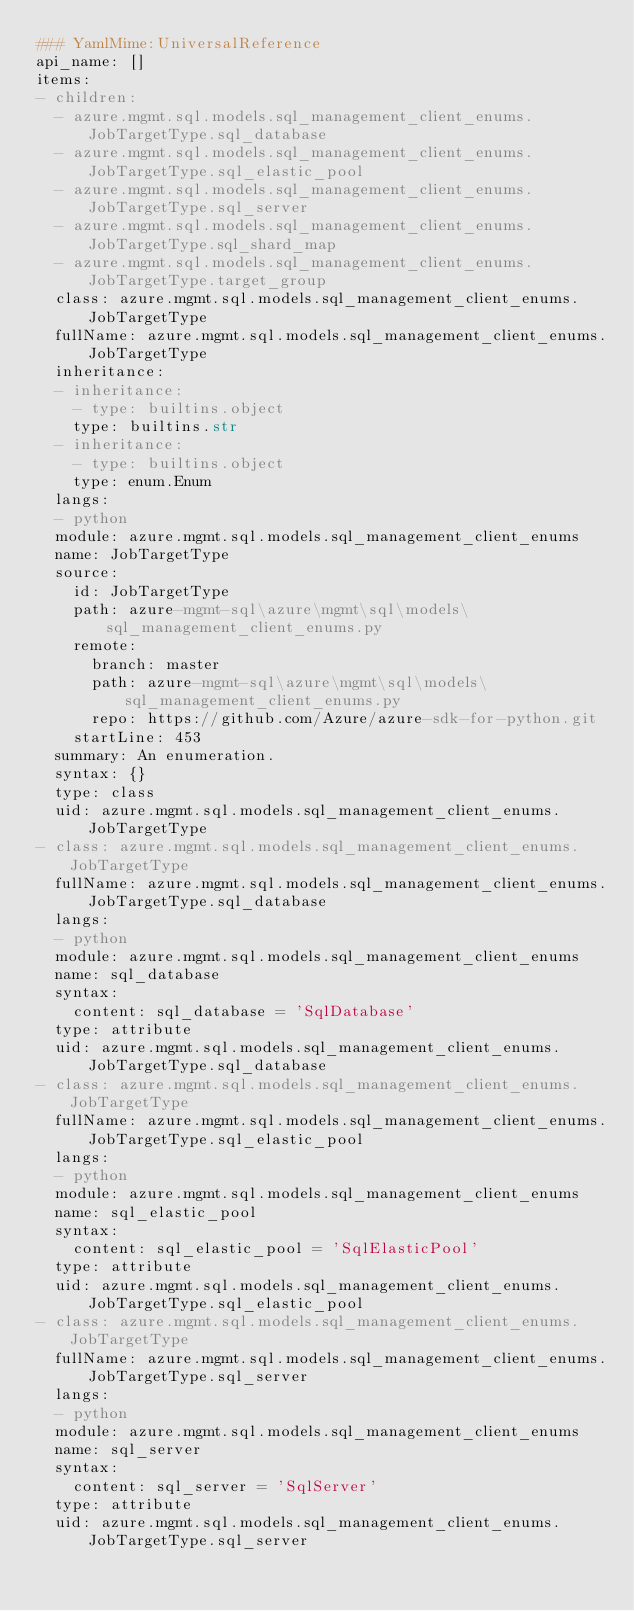Convert code to text. <code><loc_0><loc_0><loc_500><loc_500><_YAML_>### YamlMime:UniversalReference
api_name: []
items:
- children:
  - azure.mgmt.sql.models.sql_management_client_enums.JobTargetType.sql_database
  - azure.mgmt.sql.models.sql_management_client_enums.JobTargetType.sql_elastic_pool
  - azure.mgmt.sql.models.sql_management_client_enums.JobTargetType.sql_server
  - azure.mgmt.sql.models.sql_management_client_enums.JobTargetType.sql_shard_map
  - azure.mgmt.sql.models.sql_management_client_enums.JobTargetType.target_group
  class: azure.mgmt.sql.models.sql_management_client_enums.JobTargetType
  fullName: azure.mgmt.sql.models.sql_management_client_enums.JobTargetType
  inheritance:
  - inheritance:
    - type: builtins.object
    type: builtins.str
  - inheritance:
    - type: builtins.object
    type: enum.Enum
  langs:
  - python
  module: azure.mgmt.sql.models.sql_management_client_enums
  name: JobTargetType
  source:
    id: JobTargetType
    path: azure-mgmt-sql\azure\mgmt\sql\models\sql_management_client_enums.py
    remote:
      branch: master
      path: azure-mgmt-sql\azure\mgmt\sql\models\sql_management_client_enums.py
      repo: https://github.com/Azure/azure-sdk-for-python.git
    startLine: 453
  summary: An enumeration.
  syntax: {}
  type: class
  uid: azure.mgmt.sql.models.sql_management_client_enums.JobTargetType
- class: azure.mgmt.sql.models.sql_management_client_enums.JobTargetType
  fullName: azure.mgmt.sql.models.sql_management_client_enums.JobTargetType.sql_database
  langs:
  - python
  module: azure.mgmt.sql.models.sql_management_client_enums
  name: sql_database
  syntax:
    content: sql_database = 'SqlDatabase'
  type: attribute
  uid: azure.mgmt.sql.models.sql_management_client_enums.JobTargetType.sql_database
- class: azure.mgmt.sql.models.sql_management_client_enums.JobTargetType
  fullName: azure.mgmt.sql.models.sql_management_client_enums.JobTargetType.sql_elastic_pool
  langs:
  - python
  module: azure.mgmt.sql.models.sql_management_client_enums
  name: sql_elastic_pool
  syntax:
    content: sql_elastic_pool = 'SqlElasticPool'
  type: attribute
  uid: azure.mgmt.sql.models.sql_management_client_enums.JobTargetType.sql_elastic_pool
- class: azure.mgmt.sql.models.sql_management_client_enums.JobTargetType
  fullName: azure.mgmt.sql.models.sql_management_client_enums.JobTargetType.sql_server
  langs:
  - python
  module: azure.mgmt.sql.models.sql_management_client_enums
  name: sql_server
  syntax:
    content: sql_server = 'SqlServer'
  type: attribute
  uid: azure.mgmt.sql.models.sql_management_client_enums.JobTargetType.sql_server</code> 